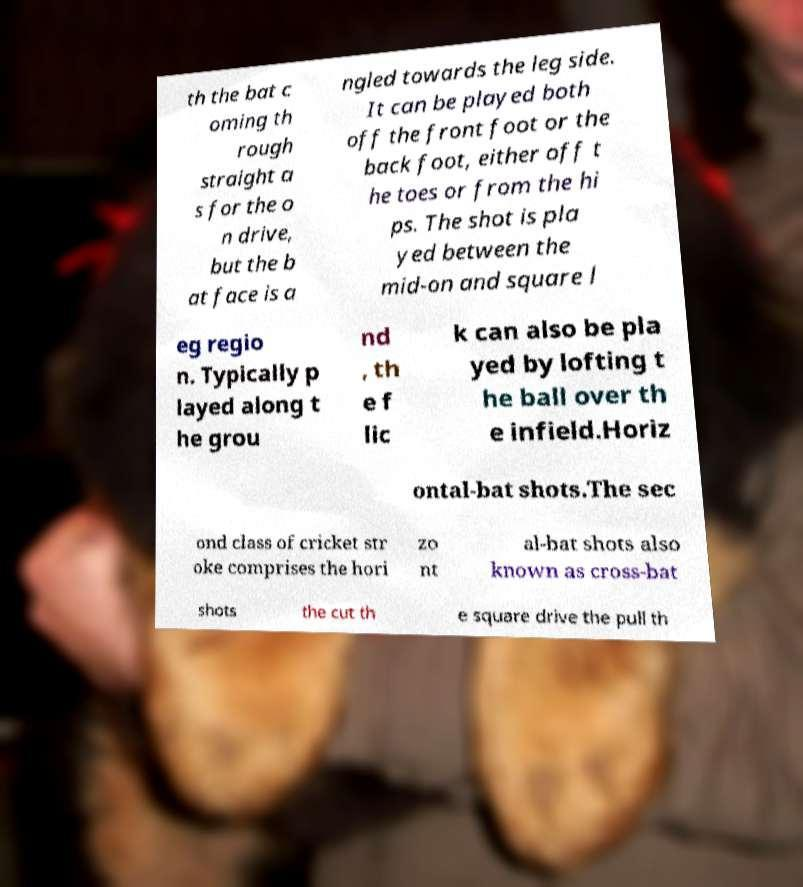I need the written content from this picture converted into text. Can you do that? th the bat c oming th rough straight a s for the o n drive, but the b at face is a ngled towards the leg side. It can be played both off the front foot or the back foot, either off t he toes or from the hi ps. The shot is pla yed between the mid-on and square l eg regio n. Typically p layed along t he grou nd , th e f lic k can also be pla yed by lofting t he ball over th e infield.Horiz ontal-bat shots.The sec ond class of cricket str oke comprises the hori zo nt al-bat shots also known as cross-bat shots the cut th e square drive the pull th 